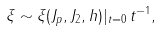Convert formula to latex. <formula><loc_0><loc_0><loc_500><loc_500>\xi \sim \xi ( J _ { p } , J _ { 2 } , h ) | _ { t = 0 } \, t ^ { - 1 } ,</formula> 